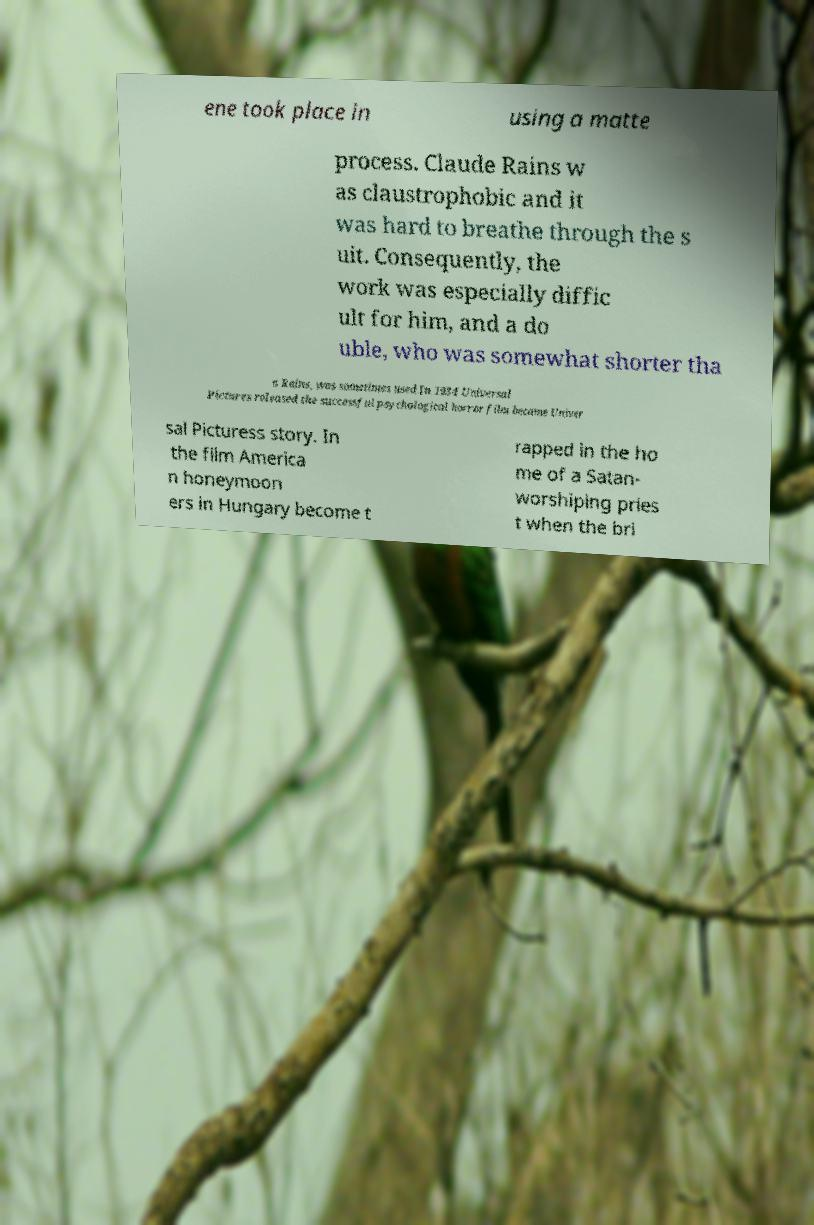Can you accurately transcribe the text from the provided image for me? ene took place in using a matte process. Claude Rains w as claustrophobic and it was hard to breathe through the s uit. Consequently, the work was especially diffic ult for him, and a do uble, who was somewhat shorter tha n Rains, was sometimes used.In 1934 Universal Pictures released the successful psychological horror film became Univer sal Picturess story. In the film America n honeymoon ers in Hungary become t rapped in the ho me of a Satan- worshiping pries t when the bri 